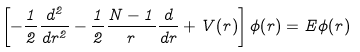Convert formula to latex. <formula><loc_0><loc_0><loc_500><loc_500>\left [ - \frac { 1 } { 2 } \frac { d ^ { 2 } } { d r ^ { 2 } } - \frac { 1 } { 2 } \frac { N - 1 } { r } \frac { d } { d r } + V ( r ) \right ] \phi ( r ) = E \phi ( r )</formula> 